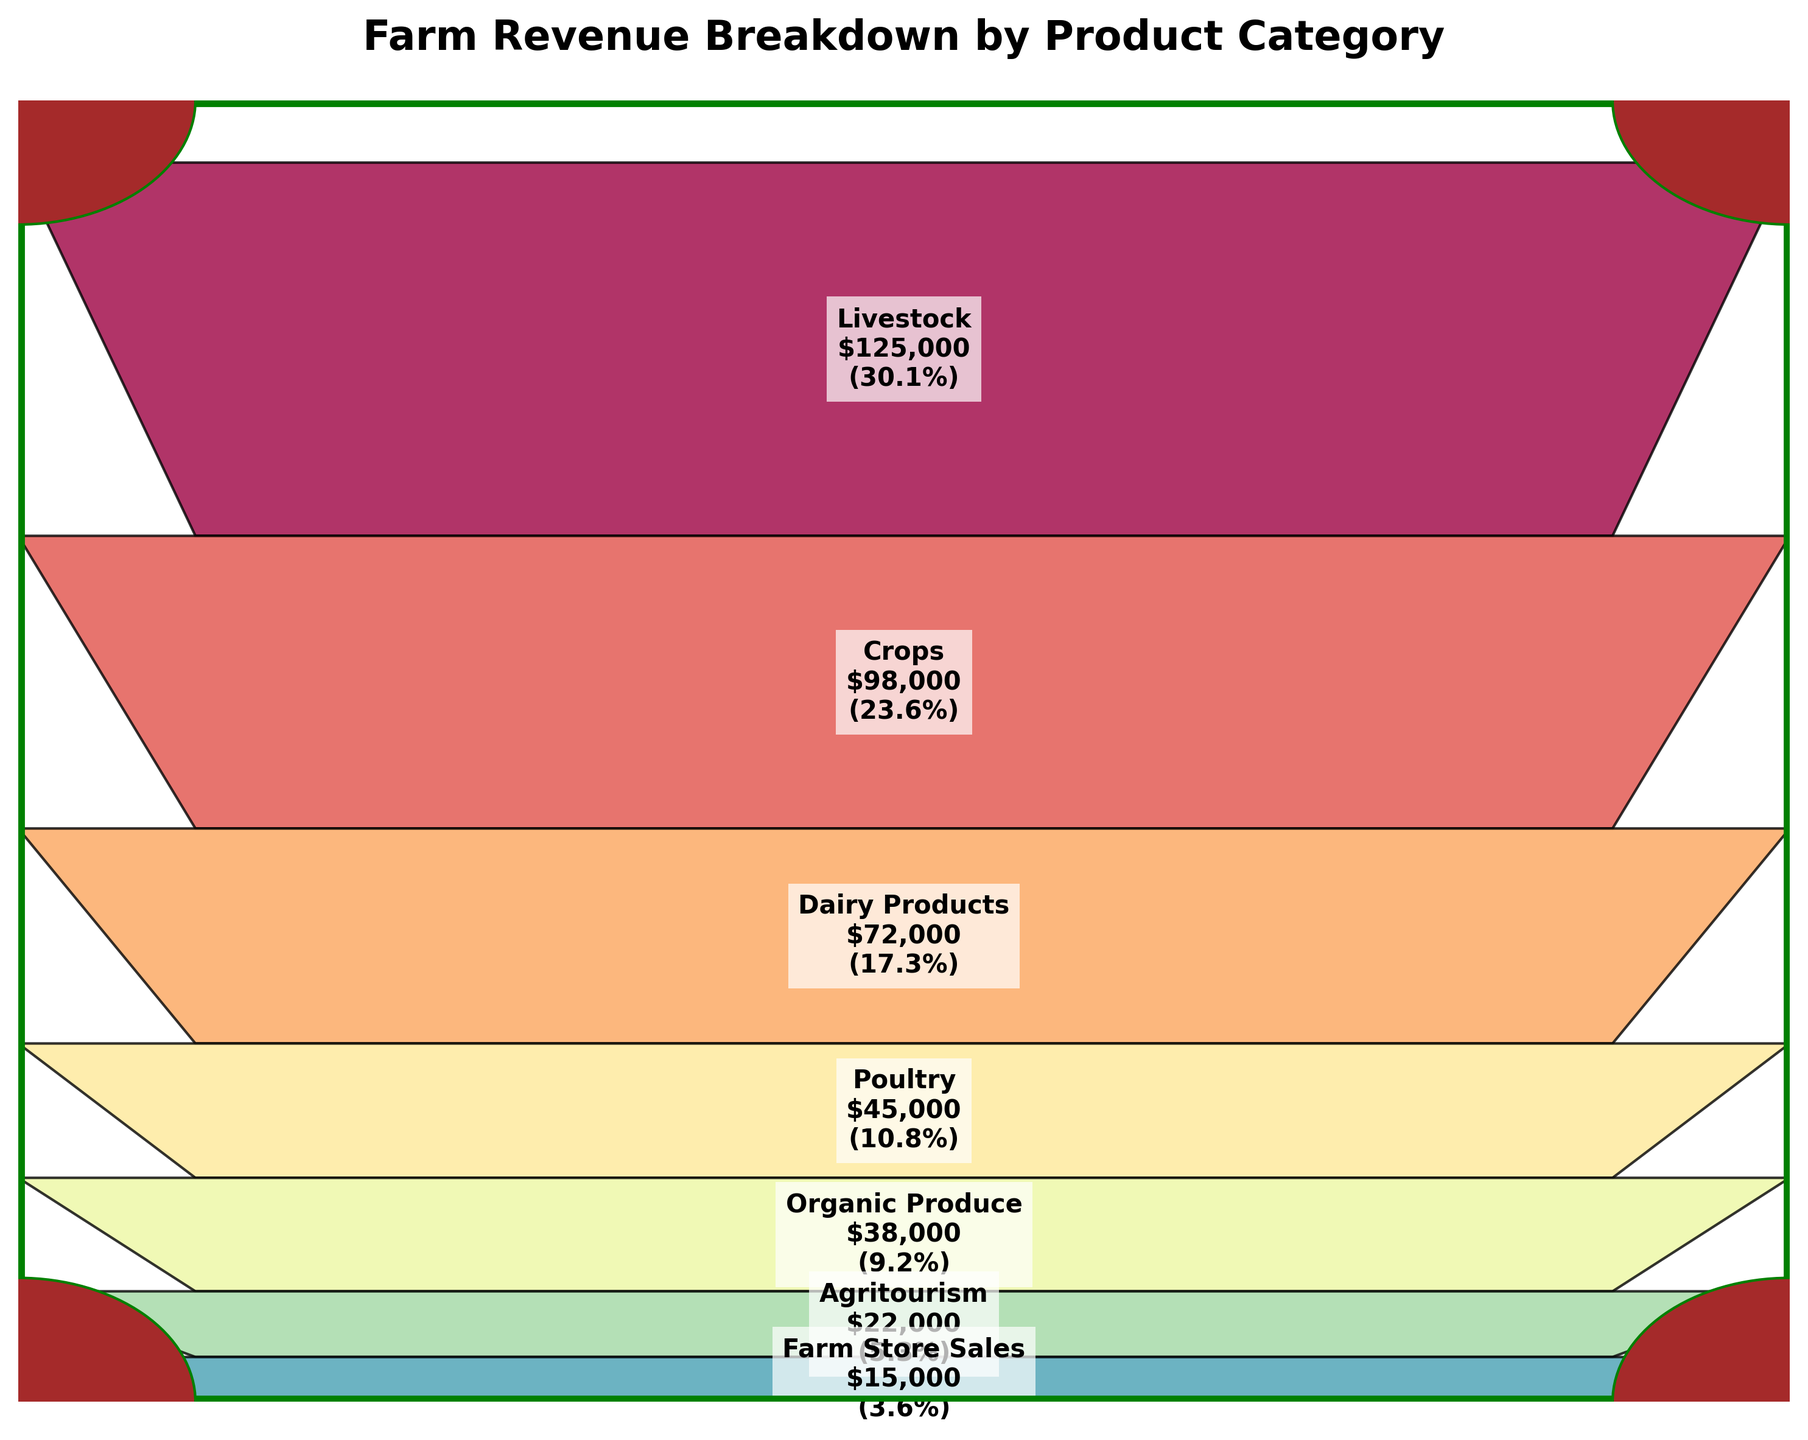What is the title of the figure? The title is located at the top of the figure and it reads "Farm Revenue Breakdown by Product Category".
Answer: Farm Revenue Breakdown by Product Category Which product category has the highest revenue? The highest segment in the funnel chart represents the category with the highest revenue, which is at the top.
Answer: Livestock How much revenue is generated from Dairy Products? With a quick glance to the segment labeled "Dairy Products" in the funnel chart, we can see the revenue figure.
Answer: $72,000 What percentage of the total revenue is contributed by Organic Produce? The percentage of revenue for each category is provided within the segment. Find the Organic Produce segment to locate this information.
Answer: 7.0% Rank the product categories from highest to lowest revenue. Analyze the funnel chart segments, starting from the top (highest revenue) to the bottom (lowest revenue). The categories are already ordered this way in the chart.
Answer: Livestock, Crops, Dairy Products, Poultry, Organic Produce, Agritourism, Farm Store Sales What is the total revenue from Livestock and Crops combined? Add the revenue figures for Livestock and Crops shown in their respective segments. Livestock is $125,000 and Crops is $98,000.
Answer: $223,000 Which product category contributes more to the revenue: Poultry or Agritourism? Compare the revenue figures within the segments for Poultry and Agritourism. Poultry has $45,000 and Agritourism has $22,000.
Answer: Poultry How much more revenue does Crops generate than Organic Produce? Subtract the revenue of Organic Produce from the revenue of Crops. Crops generate $98,000 and Organic Produce generates $38,000. The difference is $98,000 - $38,000.
Answer: $60,000 How many product categories are shown in the figure? Count the number of unique segments in the funnel chart, each representing a product category.
Answer: 7 Explain how the shape of the funnel helps in visualizing the data. The funnel shape visually narrows down from the highest to the lowest revenue categories, making it easier to see the proportional differences. Larger segments represent higher revenue contributions, while smaller segments represent lower revenue contributions. This visual cue aids in quickly understanding the distribution and significance of each category in the overall revenue.
Answer: The funnel shape highlights revenue proportions effectively 